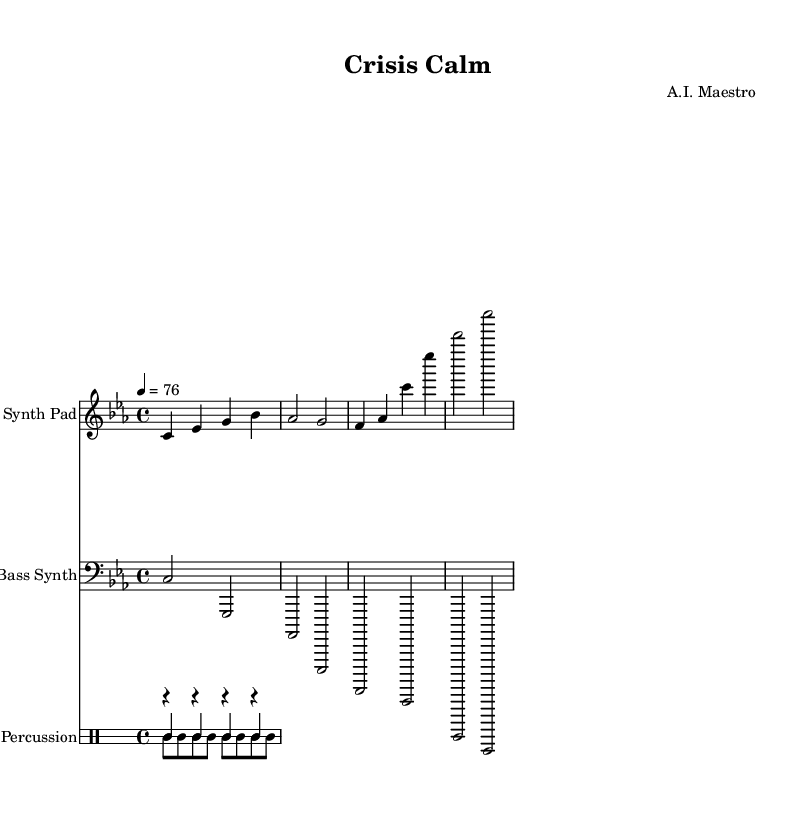What is the key signature of this music? The key signature indicated at the beginning of the piece is C minor, which has three flats (B flat, E flat, and A flat). This can be derived from the global settings defined in the code where the key is set.
Answer: C minor What is the time signature of this music? The time signature shown at the start of the piece is 4/4, meaning there are four beats in each measure, and the quarter note receives one beat. This is also specified in the global settings of the code.
Answer: 4/4 What is the tempo marking of this music? The tempo marking indicates that the piece should be played at a speed of 76 beats per minute. This is defined in the global settings under the tempo notation.
Answer: 76 How many measures are there in the Synth Pad part? The Synth Pad part contains four measures, each represented by a grouping of notes in the score. By counting the measures built in the relative structure, we find this total.
Answer: 4 What kind of percussion instruments are used in this piece? The percussion section includes a kick drum, hi-hat, and snare drum, which can be identified in the drum staff by their respective notations. These instruments are common in minimalist electronic music.
Answer: Kick drum, hi-hat, snare drum How many notes are in the first measure of the Synth Pad? The first measure of the Synth Pad contains four distinct notes, which can be observed directly from the notated music. Each note corresponds to one beat, making it easy to count.
Answer: 4 What is the range of notes in the Bass Synth part? The range of notes in the Bass Synth part spans from C to A flat, as evidenced by the lowest and highest notes notated within its measures. These notes fall within a typical bass range.
Answer: C to A flat 